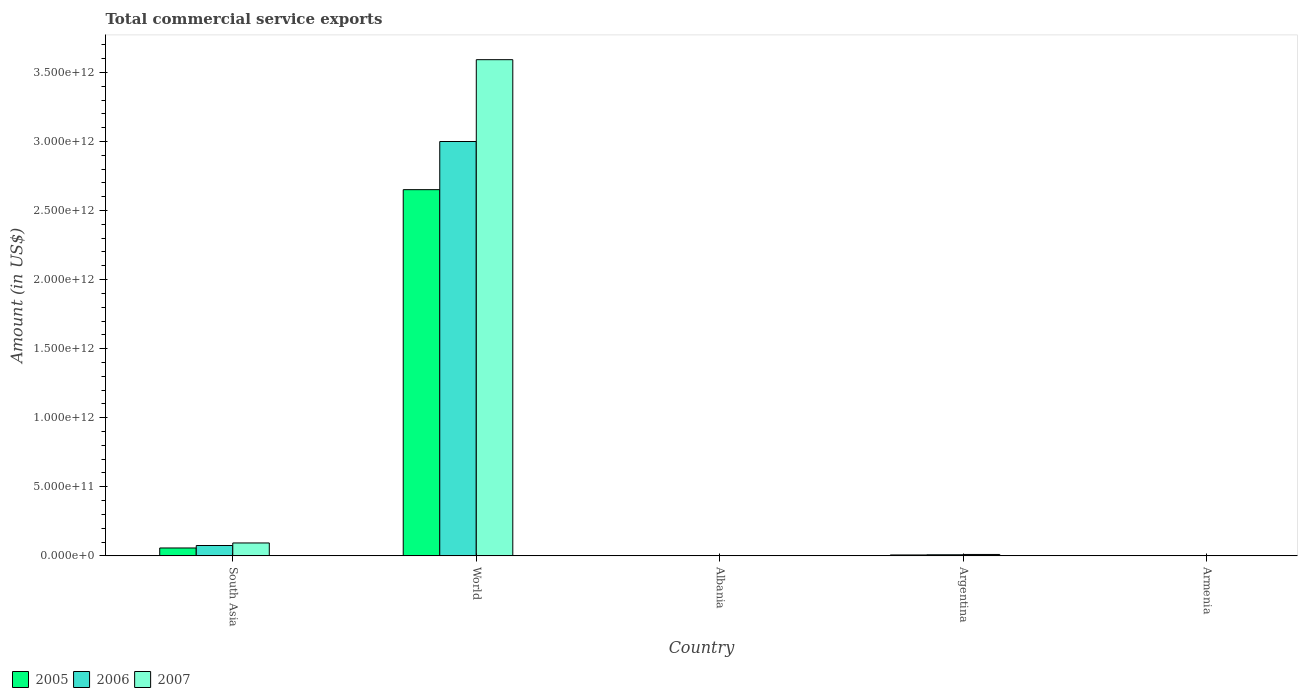Are the number of bars per tick equal to the number of legend labels?
Keep it short and to the point. Yes. Are the number of bars on each tick of the X-axis equal?
Your answer should be very brief. Yes. In how many cases, is the number of bars for a given country not equal to the number of legend labels?
Give a very brief answer. 0. What is the total commercial service exports in 2005 in World?
Make the answer very short. 2.65e+12. Across all countries, what is the maximum total commercial service exports in 2005?
Make the answer very short. 2.65e+12. Across all countries, what is the minimum total commercial service exports in 2006?
Make the answer very short. 4.87e+08. In which country was the total commercial service exports in 2005 minimum?
Offer a very short reply. Armenia. What is the total total commercial service exports in 2007 in the graph?
Ensure brevity in your answer.  3.70e+12. What is the difference between the total commercial service exports in 2005 in Armenia and that in South Asia?
Your answer should be compact. -5.65e+1. What is the difference between the total commercial service exports in 2006 in World and the total commercial service exports in 2007 in Albania?
Your answer should be very brief. 3.00e+12. What is the average total commercial service exports in 2005 per country?
Your response must be concise. 5.43e+11. What is the difference between the total commercial service exports of/in 2005 and total commercial service exports of/in 2007 in World?
Offer a terse response. -9.41e+11. What is the ratio of the total commercial service exports in 2006 in Albania to that in Armenia?
Provide a succinct answer. 3.33. Is the total commercial service exports in 2005 in Albania less than that in Argentina?
Offer a terse response. Yes. What is the difference between the highest and the second highest total commercial service exports in 2007?
Your answer should be very brief. -8.33e+1. What is the difference between the highest and the lowest total commercial service exports in 2006?
Your answer should be very brief. 3.00e+12. In how many countries, is the total commercial service exports in 2007 greater than the average total commercial service exports in 2007 taken over all countries?
Offer a very short reply. 1. What does the 3rd bar from the left in South Asia represents?
Keep it short and to the point. 2007. What does the 2nd bar from the right in Armenia represents?
Offer a very short reply. 2006. Is it the case that in every country, the sum of the total commercial service exports in 2005 and total commercial service exports in 2007 is greater than the total commercial service exports in 2006?
Make the answer very short. Yes. What is the difference between two consecutive major ticks on the Y-axis?
Your response must be concise. 5.00e+11. Does the graph contain any zero values?
Your answer should be compact. No. Does the graph contain grids?
Offer a terse response. No. Where does the legend appear in the graph?
Give a very brief answer. Bottom left. How many legend labels are there?
Your response must be concise. 3. How are the legend labels stacked?
Provide a succinct answer. Horizontal. What is the title of the graph?
Make the answer very short. Total commercial service exports. Does "1993" appear as one of the legend labels in the graph?
Provide a short and direct response. No. What is the Amount (in US$) in 2005 in South Asia?
Your answer should be very brief. 5.69e+1. What is the Amount (in US$) in 2006 in South Asia?
Keep it short and to the point. 7.48e+1. What is the Amount (in US$) in 2007 in South Asia?
Provide a short and direct response. 9.33e+1. What is the Amount (in US$) in 2005 in World?
Provide a succinct answer. 2.65e+12. What is the Amount (in US$) of 2006 in World?
Your response must be concise. 3.00e+12. What is the Amount (in US$) of 2007 in World?
Offer a terse response. 3.59e+12. What is the Amount (in US$) in 2005 in Albania?
Your response must be concise. 1.26e+09. What is the Amount (in US$) in 2006 in Albania?
Provide a succinct answer. 1.62e+09. What is the Amount (in US$) of 2007 in Albania?
Offer a terse response. 2.08e+09. What is the Amount (in US$) in 2005 in Argentina?
Offer a very short reply. 6.34e+09. What is the Amount (in US$) in 2006 in Argentina?
Provide a short and direct response. 7.71e+09. What is the Amount (in US$) in 2007 in Argentina?
Your response must be concise. 1.00e+1. What is the Amount (in US$) of 2005 in Armenia?
Give a very brief answer. 4.22e+08. What is the Amount (in US$) of 2006 in Armenia?
Make the answer very short. 4.87e+08. What is the Amount (in US$) of 2007 in Armenia?
Ensure brevity in your answer.  5.82e+08. Across all countries, what is the maximum Amount (in US$) of 2005?
Offer a terse response. 2.65e+12. Across all countries, what is the maximum Amount (in US$) in 2006?
Give a very brief answer. 3.00e+12. Across all countries, what is the maximum Amount (in US$) of 2007?
Offer a very short reply. 3.59e+12. Across all countries, what is the minimum Amount (in US$) in 2005?
Keep it short and to the point. 4.22e+08. Across all countries, what is the minimum Amount (in US$) in 2006?
Offer a very short reply. 4.87e+08. Across all countries, what is the minimum Amount (in US$) of 2007?
Offer a very short reply. 5.82e+08. What is the total Amount (in US$) in 2005 in the graph?
Make the answer very short. 2.72e+12. What is the total Amount (in US$) in 2006 in the graph?
Provide a short and direct response. 3.08e+12. What is the total Amount (in US$) in 2007 in the graph?
Provide a short and direct response. 3.70e+12. What is the difference between the Amount (in US$) in 2005 in South Asia and that in World?
Provide a short and direct response. -2.59e+12. What is the difference between the Amount (in US$) in 2006 in South Asia and that in World?
Your answer should be compact. -2.93e+12. What is the difference between the Amount (in US$) in 2007 in South Asia and that in World?
Offer a very short reply. -3.50e+12. What is the difference between the Amount (in US$) in 2005 in South Asia and that in Albania?
Your answer should be very brief. 5.57e+1. What is the difference between the Amount (in US$) in 2006 in South Asia and that in Albania?
Your answer should be very brief. 7.32e+1. What is the difference between the Amount (in US$) of 2007 in South Asia and that in Albania?
Provide a succinct answer. 9.12e+1. What is the difference between the Amount (in US$) in 2005 in South Asia and that in Argentina?
Offer a terse response. 5.06e+1. What is the difference between the Amount (in US$) of 2006 in South Asia and that in Argentina?
Make the answer very short. 6.71e+1. What is the difference between the Amount (in US$) in 2007 in South Asia and that in Argentina?
Ensure brevity in your answer.  8.33e+1. What is the difference between the Amount (in US$) in 2005 in South Asia and that in Armenia?
Your answer should be compact. 5.65e+1. What is the difference between the Amount (in US$) of 2006 in South Asia and that in Armenia?
Ensure brevity in your answer.  7.43e+1. What is the difference between the Amount (in US$) of 2007 in South Asia and that in Armenia?
Your answer should be compact. 9.27e+1. What is the difference between the Amount (in US$) in 2005 in World and that in Albania?
Make the answer very short. 2.65e+12. What is the difference between the Amount (in US$) in 2006 in World and that in Albania?
Keep it short and to the point. 3.00e+12. What is the difference between the Amount (in US$) of 2007 in World and that in Albania?
Make the answer very short. 3.59e+12. What is the difference between the Amount (in US$) of 2005 in World and that in Argentina?
Offer a terse response. 2.64e+12. What is the difference between the Amount (in US$) of 2006 in World and that in Argentina?
Ensure brevity in your answer.  2.99e+12. What is the difference between the Amount (in US$) of 2007 in World and that in Argentina?
Provide a succinct answer. 3.58e+12. What is the difference between the Amount (in US$) of 2005 in World and that in Armenia?
Your answer should be very brief. 2.65e+12. What is the difference between the Amount (in US$) of 2006 in World and that in Armenia?
Provide a succinct answer. 3.00e+12. What is the difference between the Amount (in US$) in 2007 in World and that in Armenia?
Give a very brief answer. 3.59e+12. What is the difference between the Amount (in US$) of 2005 in Albania and that in Argentina?
Provide a succinct answer. -5.09e+09. What is the difference between the Amount (in US$) in 2006 in Albania and that in Argentina?
Offer a terse response. -6.09e+09. What is the difference between the Amount (in US$) of 2007 in Albania and that in Argentina?
Your answer should be very brief. -7.92e+09. What is the difference between the Amount (in US$) of 2005 in Albania and that in Armenia?
Provide a short and direct response. 8.34e+08. What is the difference between the Amount (in US$) in 2006 in Albania and that in Armenia?
Ensure brevity in your answer.  1.14e+09. What is the difference between the Amount (in US$) of 2007 in Albania and that in Armenia?
Provide a short and direct response. 1.50e+09. What is the difference between the Amount (in US$) in 2005 in Argentina and that in Armenia?
Offer a terse response. 5.92e+09. What is the difference between the Amount (in US$) in 2006 in Argentina and that in Armenia?
Provide a short and direct response. 7.23e+09. What is the difference between the Amount (in US$) in 2007 in Argentina and that in Armenia?
Keep it short and to the point. 9.42e+09. What is the difference between the Amount (in US$) of 2005 in South Asia and the Amount (in US$) of 2006 in World?
Offer a very short reply. -2.94e+12. What is the difference between the Amount (in US$) in 2005 in South Asia and the Amount (in US$) in 2007 in World?
Provide a succinct answer. -3.54e+12. What is the difference between the Amount (in US$) of 2006 in South Asia and the Amount (in US$) of 2007 in World?
Offer a very short reply. -3.52e+12. What is the difference between the Amount (in US$) of 2005 in South Asia and the Amount (in US$) of 2006 in Albania?
Provide a short and direct response. 5.53e+1. What is the difference between the Amount (in US$) in 2005 in South Asia and the Amount (in US$) in 2007 in Albania?
Your response must be concise. 5.48e+1. What is the difference between the Amount (in US$) of 2006 in South Asia and the Amount (in US$) of 2007 in Albania?
Give a very brief answer. 7.27e+1. What is the difference between the Amount (in US$) in 2005 in South Asia and the Amount (in US$) in 2006 in Argentina?
Offer a terse response. 4.92e+1. What is the difference between the Amount (in US$) in 2005 in South Asia and the Amount (in US$) in 2007 in Argentina?
Provide a succinct answer. 4.69e+1. What is the difference between the Amount (in US$) in 2006 in South Asia and the Amount (in US$) in 2007 in Argentina?
Ensure brevity in your answer.  6.48e+1. What is the difference between the Amount (in US$) in 2005 in South Asia and the Amount (in US$) in 2006 in Armenia?
Your response must be concise. 5.64e+1. What is the difference between the Amount (in US$) in 2005 in South Asia and the Amount (in US$) in 2007 in Armenia?
Ensure brevity in your answer.  5.63e+1. What is the difference between the Amount (in US$) of 2006 in South Asia and the Amount (in US$) of 2007 in Armenia?
Offer a very short reply. 7.42e+1. What is the difference between the Amount (in US$) of 2005 in World and the Amount (in US$) of 2006 in Albania?
Provide a succinct answer. 2.65e+12. What is the difference between the Amount (in US$) of 2005 in World and the Amount (in US$) of 2007 in Albania?
Ensure brevity in your answer.  2.65e+12. What is the difference between the Amount (in US$) in 2006 in World and the Amount (in US$) in 2007 in Albania?
Give a very brief answer. 3.00e+12. What is the difference between the Amount (in US$) of 2005 in World and the Amount (in US$) of 2006 in Argentina?
Ensure brevity in your answer.  2.64e+12. What is the difference between the Amount (in US$) of 2005 in World and the Amount (in US$) of 2007 in Argentina?
Ensure brevity in your answer.  2.64e+12. What is the difference between the Amount (in US$) in 2006 in World and the Amount (in US$) in 2007 in Argentina?
Keep it short and to the point. 2.99e+12. What is the difference between the Amount (in US$) of 2005 in World and the Amount (in US$) of 2006 in Armenia?
Your response must be concise. 2.65e+12. What is the difference between the Amount (in US$) in 2005 in World and the Amount (in US$) in 2007 in Armenia?
Ensure brevity in your answer.  2.65e+12. What is the difference between the Amount (in US$) of 2006 in World and the Amount (in US$) of 2007 in Armenia?
Make the answer very short. 3.00e+12. What is the difference between the Amount (in US$) in 2005 in Albania and the Amount (in US$) in 2006 in Argentina?
Provide a short and direct response. -6.46e+09. What is the difference between the Amount (in US$) of 2005 in Albania and the Amount (in US$) of 2007 in Argentina?
Ensure brevity in your answer.  -8.75e+09. What is the difference between the Amount (in US$) of 2006 in Albania and the Amount (in US$) of 2007 in Argentina?
Your response must be concise. -8.38e+09. What is the difference between the Amount (in US$) in 2005 in Albania and the Amount (in US$) in 2006 in Armenia?
Your response must be concise. 7.69e+08. What is the difference between the Amount (in US$) of 2005 in Albania and the Amount (in US$) of 2007 in Armenia?
Your response must be concise. 6.75e+08. What is the difference between the Amount (in US$) of 2006 in Albania and the Amount (in US$) of 2007 in Armenia?
Offer a terse response. 1.04e+09. What is the difference between the Amount (in US$) in 2005 in Argentina and the Amount (in US$) in 2006 in Armenia?
Make the answer very short. 5.86e+09. What is the difference between the Amount (in US$) of 2005 in Argentina and the Amount (in US$) of 2007 in Armenia?
Your answer should be very brief. 5.76e+09. What is the difference between the Amount (in US$) of 2006 in Argentina and the Amount (in US$) of 2007 in Armenia?
Your answer should be compact. 7.13e+09. What is the average Amount (in US$) of 2005 per country?
Your answer should be very brief. 5.43e+11. What is the average Amount (in US$) in 2006 per country?
Make the answer very short. 6.17e+11. What is the average Amount (in US$) of 2007 per country?
Give a very brief answer. 7.40e+11. What is the difference between the Amount (in US$) in 2005 and Amount (in US$) in 2006 in South Asia?
Offer a terse response. -1.79e+1. What is the difference between the Amount (in US$) in 2005 and Amount (in US$) in 2007 in South Asia?
Provide a short and direct response. -3.64e+1. What is the difference between the Amount (in US$) in 2006 and Amount (in US$) in 2007 in South Asia?
Provide a succinct answer. -1.85e+1. What is the difference between the Amount (in US$) of 2005 and Amount (in US$) of 2006 in World?
Provide a short and direct response. -3.49e+11. What is the difference between the Amount (in US$) of 2005 and Amount (in US$) of 2007 in World?
Offer a very short reply. -9.41e+11. What is the difference between the Amount (in US$) of 2006 and Amount (in US$) of 2007 in World?
Provide a succinct answer. -5.92e+11. What is the difference between the Amount (in US$) in 2005 and Amount (in US$) in 2006 in Albania?
Ensure brevity in your answer.  -3.67e+08. What is the difference between the Amount (in US$) of 2005 and Amount (in US$) of 2007 in Albania?
Provide a short and direct response. -8.26e+08. What is the difference between the Amount (in US$) of 2006 and Amount (in US$) of 2007 in Albania?
Offer a terse response. -4.59e+08. What is the difference between the Amount (in US$) in 2005 and Amount (in US$) in 2006 in Argentina?
Offer a terse response. -1.37e+09. What is the difference between the Amount (in US$) of 2005 and Amount (in US$) of 2007 in Argentina?
Give a very brief answer. -3.66e+09. What is the difference between the Amount (in US$) of 2006 and Amount (in US$) of 2007 in Argentina?
Provide a succinct answer. -2.29e+09. What is the difference between the Amount (in US$) in 2005 and Amount (in US$) in 2006 in Armenia?
Your response must be concise. -6.57e+07. What is the difference between the Amount (in US$) of 2005 and Amount (in US$) of 2007 in Armenia?
Offer a terse response. -1.60e+08. What is the difference between the Amount (in US$) in 2006 and Amount (in US$) in 2007 in Armenia?
Your answer should be compact. -9.43e+07. What is the ratio of the Amount (in US$) of 2005 in South Asia to that in World?
Give a very brief answer. 0.02. What is the ratio of the Amount (in US$) of 2006 in South Asia to that in World?
Your answer should be very brief. 0.02. What is the ratio of the Amount (in US$) of 2007 in South Asia to that in World?
Give a very brief answer. 0.03. What is the ratio of the Amount (in US$) of 2005 in South Asia to that in Albania?
Keep it short and to the point. 45.3. What is the ratio of the Amount (in US$) in 2006 in South Asia to that in Albania?
Your answer should be very brief. 46.1. What is the ratio of the Amount (in US$) in 2007 in South Asia to that in Albania?
Keep it short and to the point. 44.79. What is the ratio of the Amount (in US$) of 2005 in South Asia to that in Argentina?
Make the answer very short. 8.97. What is the ratio of the Amount (in US$) of 2006 in South Asia to that in Argentina?
Your answer should be very brief. 9.7. What is the ratio of the Amount (in US$) of 2007 in South Asia to that in Argentina?
Your response must be concise. 9.32. What is the ratio of the Amount (in US$) in 2005 in South Asia to that in Armenia?
Offer a terse response. 134.93. What is the ratio of the Amount (in US$) of 2006 in South Asia to that in Armenia?
Offer a very short reply. 153.51. What is the ratio of the Amount (in US$) in 2007 in South Asia to that in Armenia?
Provide a short and direct response. 160.36. What is the ratio of the Amount (in US$) of 2005 in World to that in Albania?
Give a very brief answer. 2110.43. What is the ratio of the Amount (in US$) of 2006 in World to that in Albania?
Offer a terse response. 1848.32. What is the ratio of the Amount (in US$) of 2007 in World to that in Albania?
Your answer should be compact. 1724.98. What is the ratio of the Amount (in US$) of 2005 in World to that in Argentina?
Offer a very short reply. 417.99. What is the ratio of the Amount (in US$) in 2006 in World to that in Argentina?
Your answer should be very brief. 388.92. What is the ratio of the Amount (in US$) of 2007 in World to that in Argentina?
Offer a very short reply. 359. What is the ratio of the Amount (in US$) in 2005 in World to that in Armenia?
Your answer should be very brief. 6285.44. What is the ratio of the Amount (in US$) of 2006 in World to that in Armenia?
Provide a short and direct response. 6154.1. What is the ratio of the Amount (in US$) in 2007 in World to that in Armenia?
Your answer should be compact. 6175.11. What is the ratio of the Amount (in US$) of 2005 in Albania to that in Argentina?
Offer a very short reply. 0.2. What is the ratio of the Amount (in US$) in 2006 in Albania to that in Argentina?
Your answer should be very brief. 0.21. What is the ratio of the Amount (in US$) in 2007 in Albania to that in Argentina?
Keep it short and to the point. 0.21. What is the ratio of the Amount (in US$) of 2005 in Albania to that in Armenia?
Your answer should be compact. 2.98. What is the ratio of the Amount (in US$) in 2006 in Albania to that in Armenia?
Ensure brevity in your answer.  3.33. What is the ratio of the Amount (in US$) in 2007 in Albania to that in Armenia?
Your response must be concise. 3.58. What is the ratio of the Amount (in US$) in 2005 in Argentina to that in Armenia?
Offer a terse response. 15.04. What is the ratio of the Amount (in US$) of 2006 in Argentina to that in Armenia?
Offer a very short reply. 15.82. What is the ratio of the Amount (in US$) in 2007 in Argentina to that in Armenia?
Provide a short and direct response. 17.2. What is the difference between the highest and the second highest Amount (in US$) of 2005?
Provide a succinct answer. 2.59e+12. What is the difference between the highest and the second highest Amount (in US$) in 2006?
Offer a terse response. 2.93e+12. What is the difference between the highest and the second highest Amount (in US$) in 2007?
Offer a very short reply. 3.50e+12. What is the difference between the highest and the lowest Amount (in US$) in 2005?
Ensure brevity in your answer.  2.65e+12. What is the difference between the highest and the lowest Amount (in US$) of 2006?
Make the answer very short. 3.00e+12. What is the difference between the highest and the lowest Amount (in US$) in 2007?
Offer a very short reply. 3.59e+12. 